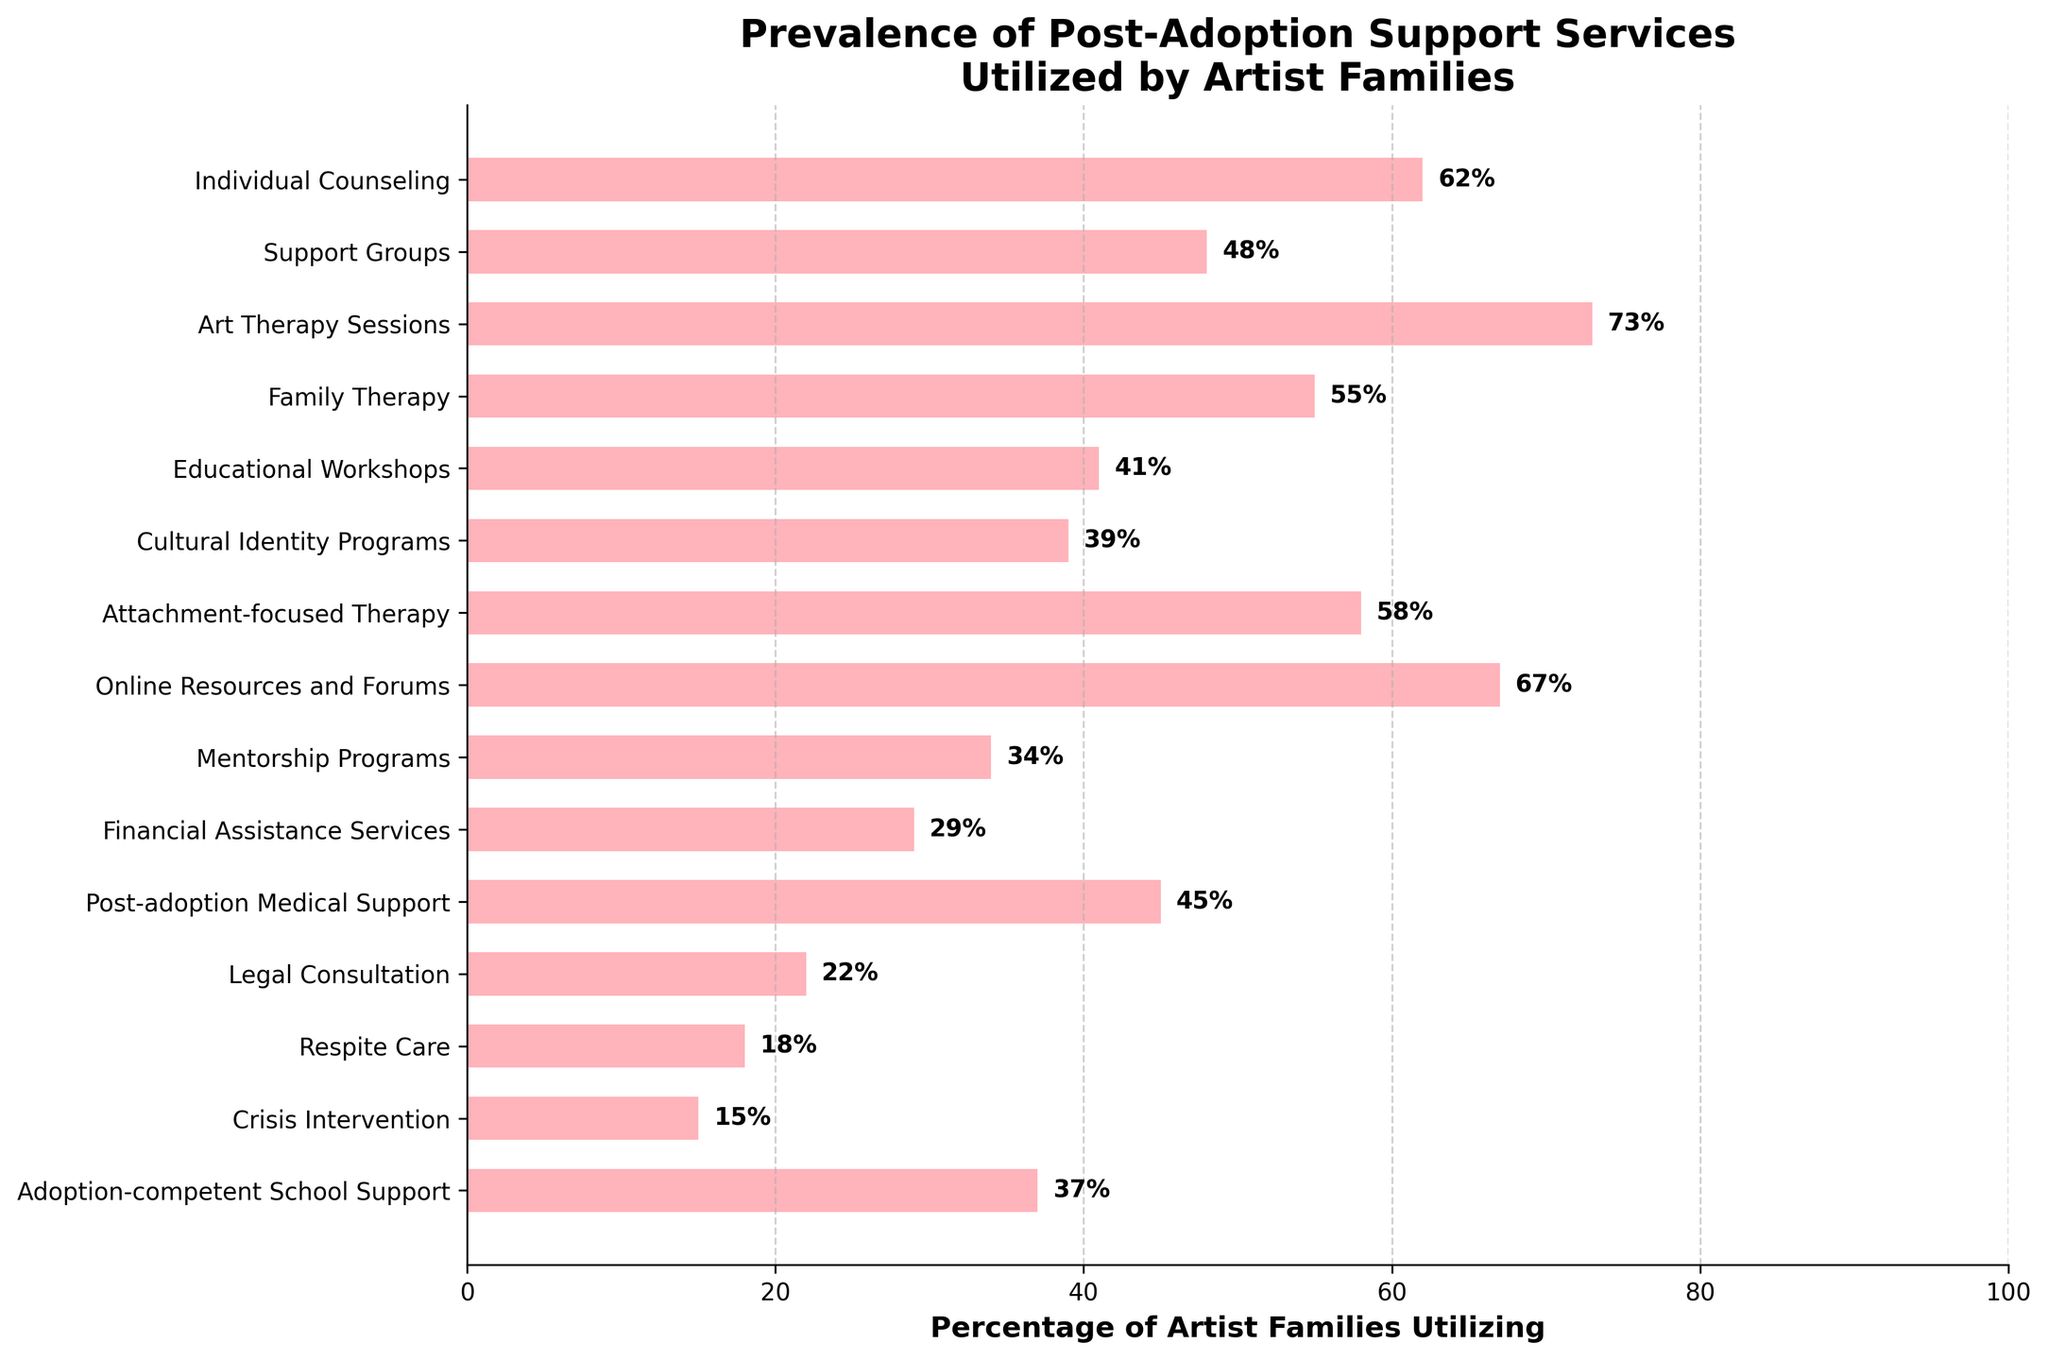Which service has the highest percentage of artist families utilizing it? By looking at the lengths of the bars, it's clear that the bar for Art Therapy Sessions is the longest.
Answer: Art Therapy Sessions Which service has the lowest percentage of artist families utilizing it? The shortest bar represents Crisis Intervention, indicating it has the lowest percentage.
Answer: Crisis Intervention What's the difference in utilization percentage between Family Therapy and Individual Counseling? The percentage for Individual Counseling is 62% and for Family Therapy is 55%. The difference is 62% - 55% = 7%.
Answer: 7% What is the average percentage of utilization for Individual Counseling, Support Groups, Family Therapy, and Educational Workshops? To find the average, sum the percentages first: 62 + 48 + 55 + 41 = 206. Then divide by the number of services (4). 206 / 4 = 51.5%.
Answer: 51.5% Which service has a higher utilization percentage, Online Resources and Forums or Attachment-focused Therapy, and by how much? Online Resources and Forums has 67%, while Attachment-focused Therapy has 58%. The difference is 67% - 58% = 9%.
Answer: Online Resources and Forums by 9% Is the percentage of artist families utilizing Financial Assistance Services greater than those utilizing Mentorship Programs? Financial Assistance Services is at 29%, while Mentorship Programs is at 34%. 29% is less than 34%.
Answer: No If the percentages of Support Groups and Educational Workshops are combined, do they surpass the percentage of Art Therapy Sessions? Support Groups are at 48%, and Educational Workshops are at 41%. Combined, they make 48% + 41% = 89%. Art Therapy Sessions are at 73%, which is less than 89%.
Answer: Yes Which two services have the closest utilization percentages, and what are those percentages? The closest percentages are Educational Workshops at 41% and Cultural Identity Programs at 39%, giving a difference of 2%.
Answer: Educational Workshops and Cultural Identity Programs at 41% and 39% How many services have a utilization percentage greater than 50%? The services with percentages greater than 50% are Individual Counseling (62%), Art Therapy Sessions (73%), Family Therapy (55%), Attachment-focused Therapy (58%), and Online Resources and Forums (67%). In total, there are 5 services.
Answer: 5 What percentage of artist families utilize Legal Consultation services? The bar for Legal Consultation indicates a utilization percentage of 22%.
Answer: 22% 